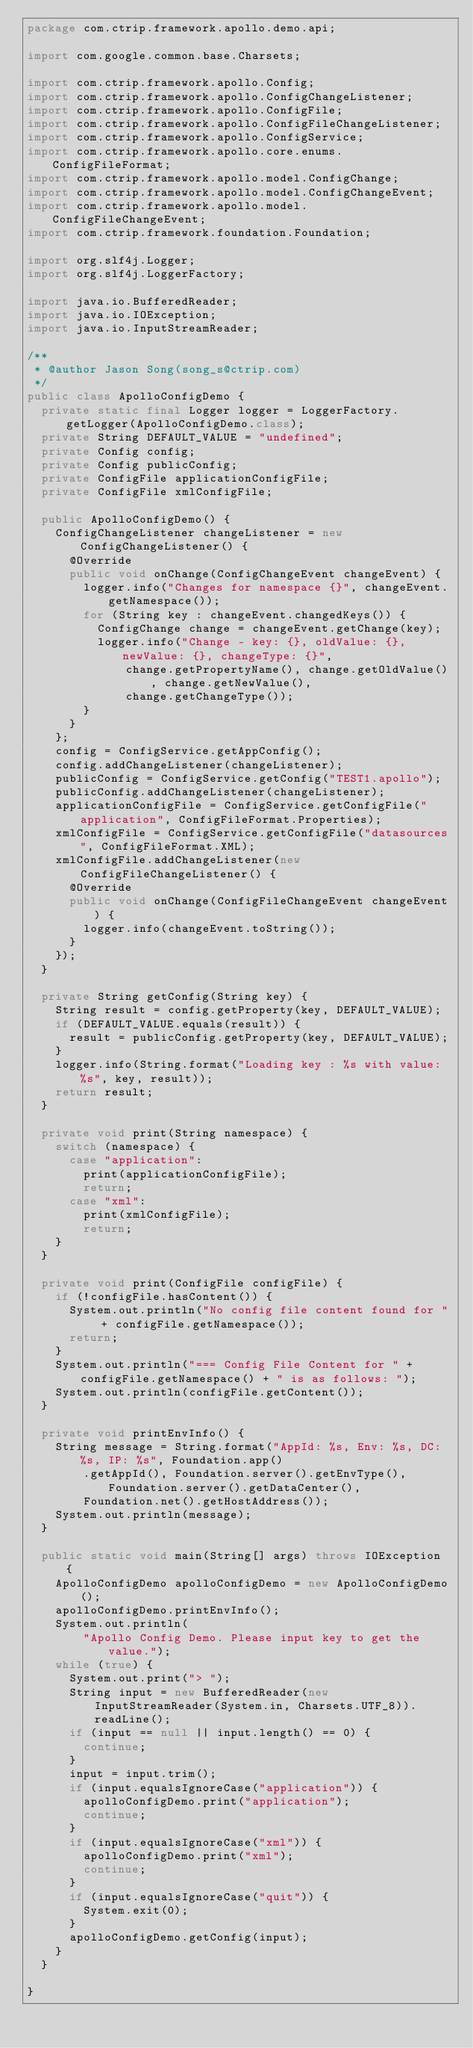<code> <loc_0><loc_0><loc_500><loc_500><_Java_>package com.ctrip.framework.apollo.demo.api;

import com.google.common.base.Charsets;

import com.ctrip.framework.apollo.Config;
import com.ctrip.framework.apollo.ConfigChangeListener;
import com.ctrip.framework.apollo.ConfigFile;
import com.ctrip.framework.apollo.ConfigFileChangeListener;
import com.ctrip.framework.apollo.ConfigService;
import com.ctrip.framework.apollo.core.enums.ConfigFileFormat;
import com.ctrip.framework.apollo.model.ConfigChange;
import com.ctrip.framework.apollo.model.ConfigChangeEvent;
import com.ctrip.framework.apollo.model.ConfigFileChangeEvent;
import com.ctrip.framework.foundation.Foundation;

import org.slf4j.Logger;
import org.slf4j.LoggerFactory;

import java.io.BufferedReader;
import java.io.IOException;
import java.io.InputStreamReader;

/**
 * @author Jason Song(song_s@ctrip.com)
 */
public class ApolloConfigDemo {
  private static final Logger logger = LoggerFactory.getLogger(ApolloConfigDemo.class);
  private String DEFAULT_VALUE = "undefined";
  private Config config;
  private Config publicConfig;
  private ConfigFile applicationConfigFile;
  private ConfigFile xmlConfigFile;

  public ApolloConfigDemo() {
    ConfigChangeListener changeListener = new ConfigChangeListener() {
      @Override
      public void onChange(ConfigChangeEvent changeEvent) {
        logger.info("Changes for namespace {}", changeEvent.getNamespace());
        for (String key : changeEvent.changedKeys()) {
          ConfigChange change = changeEvent.getChange(key);
          logger.info("Change - key: {}, oldValue: {}, newValue: {}, changeType: {}",
              change.getPropertyName(), change.getOldValue(), change.getNewValue(),
              change.getChangeType());
        }
      }
    };
    config = ConfigService.getAppConfig();
    config.addChangeListener(changeListener);
    publicConfig = ConfigService.getConfig("TEST1.apollo");
    publicConfig.addChangeListener(changeListener);
    applicationConfigFile = ConfigService.getConfigFile("application", ConfigFileFormat.Properties);
    xmlConfigFile = ConfigService.getConfigFile("datasources", ConfigFileFormat.XML);
    xmlConfigFile.addChangeListener(new ConfigFileChangeListener() {
      @Override
      public void onChange(ConfigFileChangeEvent changeEvent) {
        logger.info(changeEvent.toString());
      }
    });
  }

  private String getConfig(String key) {
    String result = config.getProperty(key, DEFAULT_VALUE);
    if (DEFAULT_VALUE.equals(result)) {
      result = publicConfig.getProperty(key, DEFAULT_VALUE);
    }
    logger.info(String.format("Loading key : %s with value: %s", key, result));
    return result;
  }

  private void print(String namespace) {
    switch (namespace) {
      case "application":
        print(applicationConfigFile);
        return;
      case "xml":
        print(xmlConfigFile);
        return;
    }
  }

  private void print(ConfigFile configFile) {
    if (!configFile.hasContent()) {
      System.out.println("No config file content found for " + configFile.getNamespace());
      return;
    }
    System.out.println("=== Config File Content for " + configFile.getNamespace() + " is as follows: ");
    System.out.println(configFile.getContent());
  }

  private void printEnvInfo() {
    String message = String.format("AppId: %s, Env: %s, DC: %s, IP: %s", Foundation.app()
        .getAppId(), Foundation.server().getEnvType(), Foundation.server().getDataCenter(),
        Foundation.net().getHostAddress());
    System.out.println(message);
  }

  public static void main(String[] args) throws IOException {
    ApolloConfigDemo apolloConfigDemo = new ApolloConfigDemo();
    apolloConfigDemo.printEnvInfo();
    System.out.println(
        "Apollo Config Demo. Please input key to get the value.");
    while (true) {
      System.out.print("> ");
      String input = new BufferedReader(new InputStreamReader(System.in, Charsets.UTF_8)).readLine();
      if (input == null || input.length() == 0) {
        continue;
      }
      input = input.trim();
      if (input.equalsIgnoreCase("application")) {
        apolloConfigDemo.print("application");
        continue;
      }
      if (input.equalsIgnoreCase("xml")) {
        apolloConfigDemo.print("xml");
        continue;
      }
      if (input.equalsIgnoreCase("quit")) {
        System.exit(0);
      }
      apolloConfigDemo.getConfig(input);
    }
  }

}
</code> 